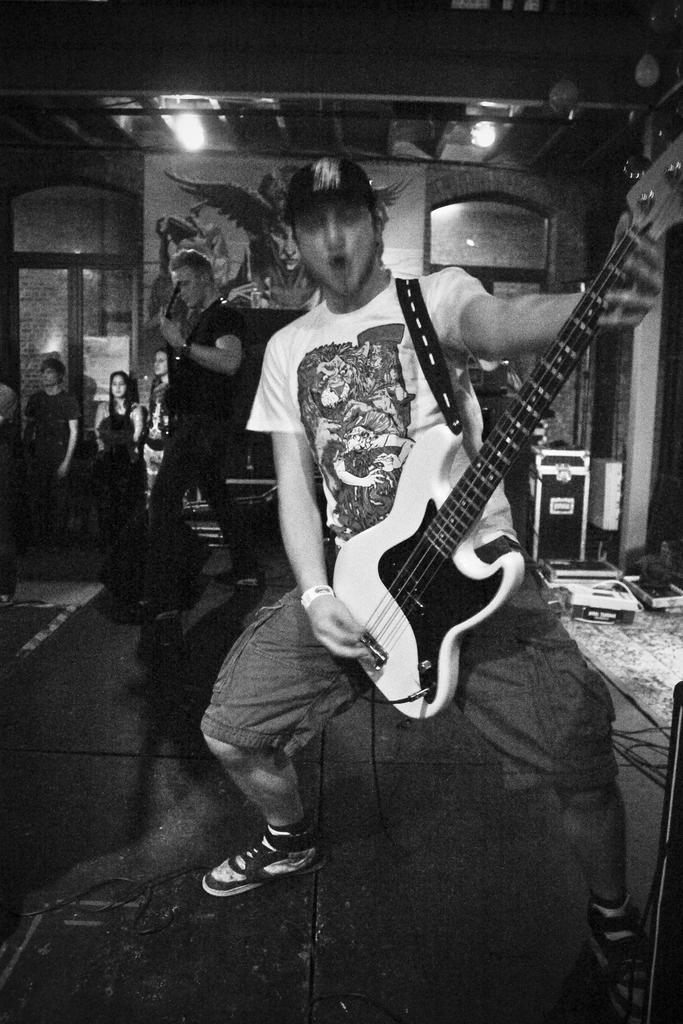What is happening in the room in the image? There are people standing in a room. What is the man holding in the image? The man is holding a guitar. What is the man doing with the guitar? The man is playing the guitar. Can you tell me how many sweaters are being worn by the people in the image? There is no information about sweaters in the image, so it cannot be determined how many are being worn. What type of tray is being used by the man to play the guitar? There is no tray present in the image; the man is playing the guitar without any additional objects. 